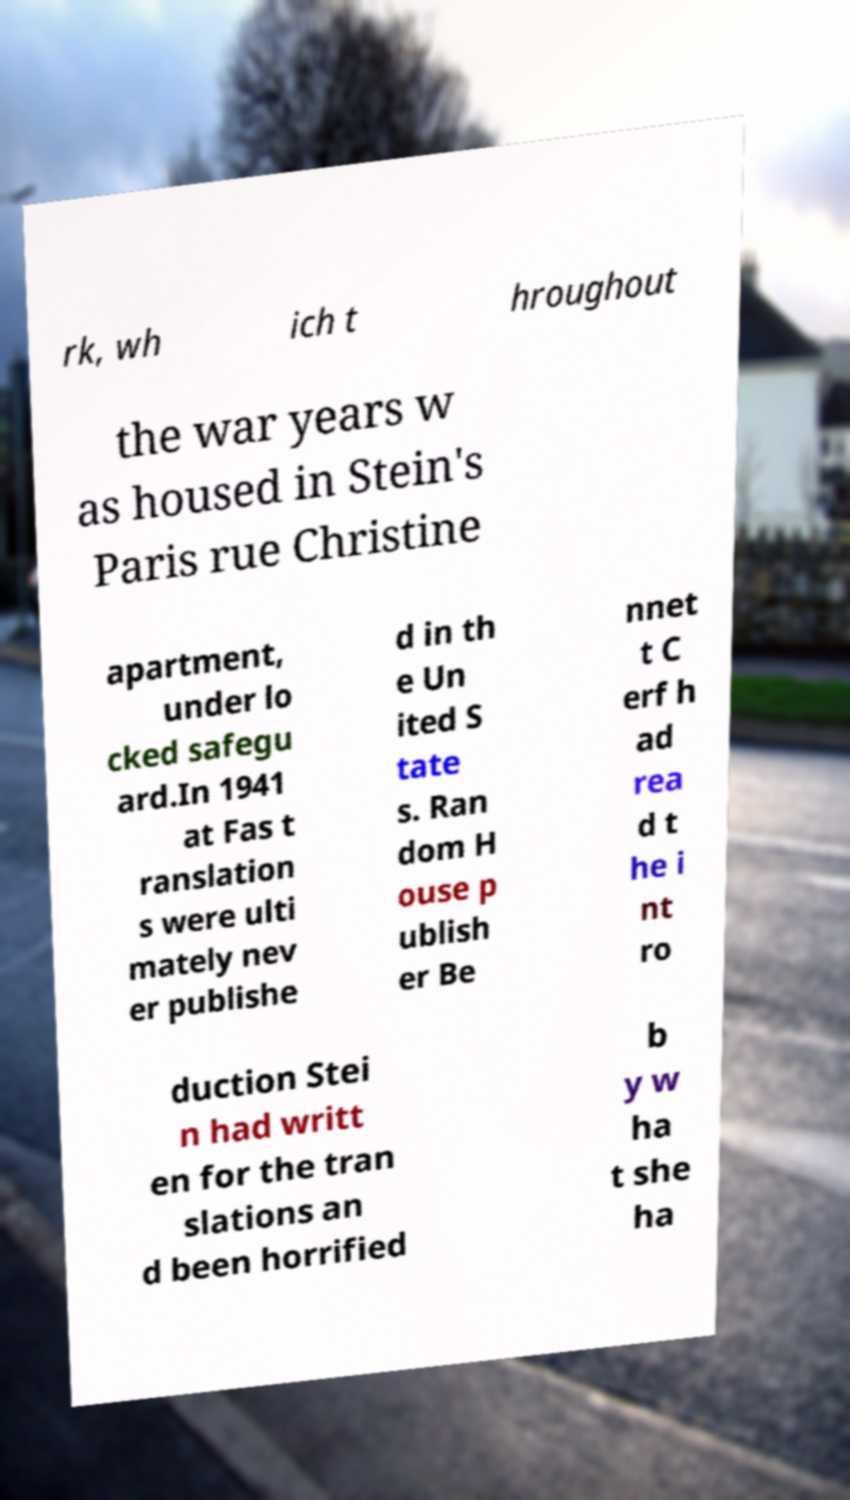Can you read and provide the text displayed in the image?This photo seems to have some interesting text. Can you extract and type it out for me? rk, wh ich t hroughout the war years w as housed in Stein's Paris rue Christine apartment, under lo cked safegu ard.In 1941 at Fas t ranslation s were ulti mately nev er publishe d in th e Un ited S tate s. Ran dom H ouse p ublish er Be nnet t C erf h ad rea d t he i nt ro duction Stei n had writt en for the tran slations an d been horrified b y w ha t she ha 